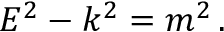<formula> <loc_0><loc_0><loc_500><loc_500>E ^ { 2 } - k ^ { 2 } = m ^ { 2 } \, .</formula> 